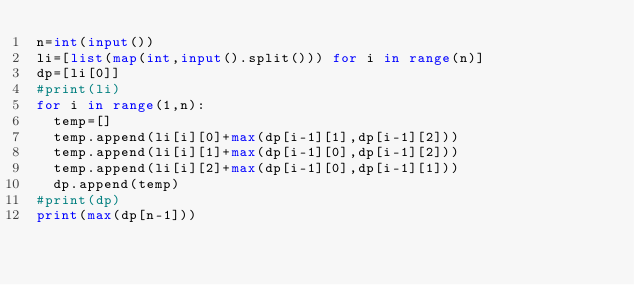Convert code to text. <code><loc_0><loc_0><loc_500><loc_500><_Python_>n=int(input())
li=[list(map(int,input().split())) for i in range(n)]
dp=[li[0]]
#print(li)
for i in range(1,n):
  temp=[]
  temp.append(li[i][0]+max(dp[i-1][1],dp[i-1][2]))
  temp.append(li[i][1]+max(dp[i-1][0],dp[i-1][2]))
  temp.append(li[i][2]+max(dp[i-1][0],dp[i-1][1]))
  dp.append(temp)
#print(dp)
print(max(dp[n-1]))</code> 